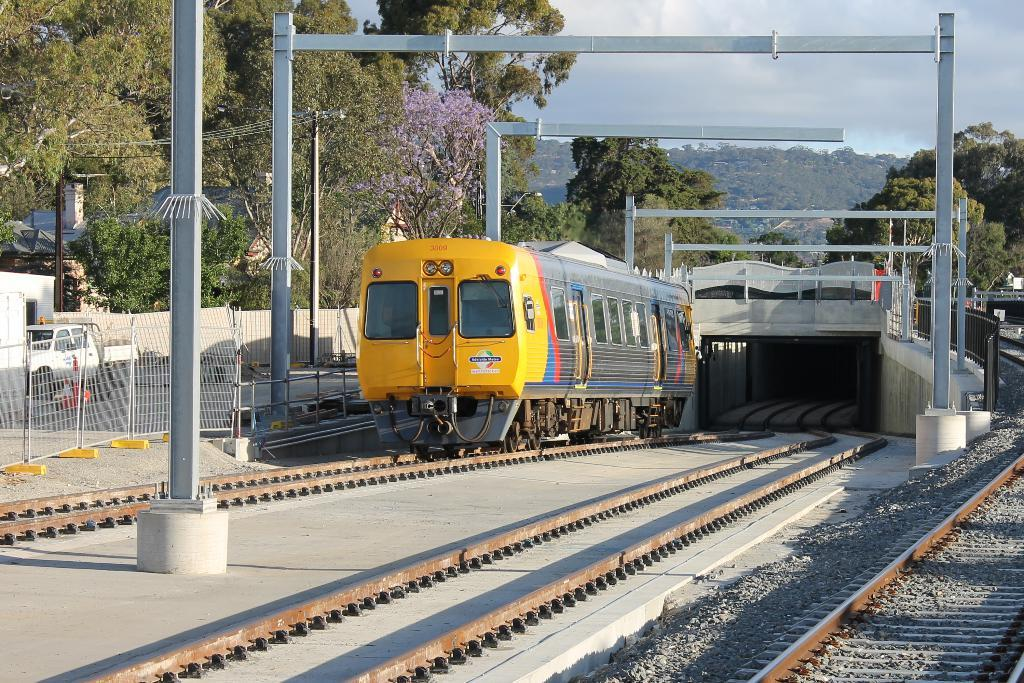What can be seen in the foreground of the image? In the foreground of the image, there are tracks, poles, and a train. What is visible in the background of the image? In the background of the image, there are trees, a vehicle, a boundary, mountains, and the sky. Can you describe the train in the foreground? The train in the foreground is located on the tracks and is likely a mode of transportation. What type of natural feature is depicted in the background? Mountains can be seen in the background of the image. How many cherries are hanging from the poles in the image? There are no cherries present in the image; the poles are part of the train tracks. What type of wealth is depicted in the image? There is no depiction of wealth in the image; it features a train, tracks, and natural scenery. 